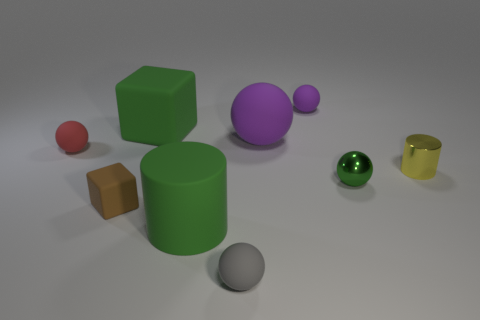Subtract all green spheres. How many spheres are left? 4 Subtract all cyan blocks. Subtract all green spheres. How many blocks are left? 2 Subtract all cylinders. How many objects are left? 7 Add 1 tiny brown matte objects. How many tiny brown matte objects exist? 2 Subtract 0 red cylinders. How many objects are left? 9 Subtract all red metal cylinders. Subtract all green rubber things. How many objects are left? 7 Add 1 small brown rubber objects. How many small brown rubber objects are left? 2 